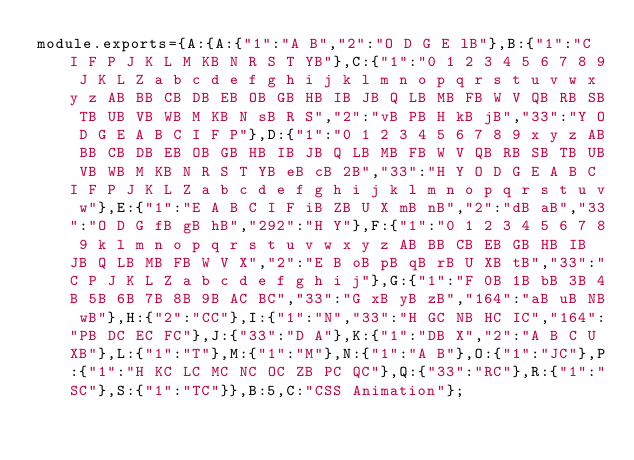Convert code to text. <code><loc_0><loc_0><loc_500><loc_500><_JavaScript_>module.exports={A:{A:{"1":"A B","2":"O D G E lB"},B:{"1":"C I F P J K L M KB N R S T YB"},C:{"1":"0 1 2 3 4 5 6 7 8 9 J K L Z a b c d e f g h i j k l m n o p q r s t u v w x y z AB BB CB DB EB OB GB HB IB JB Q LB MB FB W V QB RB SB TB UB VB WB M KB N sB R S","2":"vB PB H kB jB","33":"Y O D G E A B C I F P"},D:{"1":"0 1 2 3 4 5 6 7 8 9 x y z AB BB CB DB EB OB GB HB IB JB Q LB MB FB W V QB RB SB TB UB VB WB M KB N R S T YB eB cB 2B","33":"H Y O D G E A B C I F P J K L Z a b c d e f g h i j k l m n o p q r s t u v w"},E:{"1":"E A B C I F iB ZB U X mB nB","2":"dB aB","33":"O D G fB gB hB","292":"H Y"},F:{"1":"0 1 2 3 4 5 6 7 8 9 k l m n o p q r s t u v w x y z AB BB CB EB GB HB IB JB Q LB MB FB W V X","2":"E B oB pB qB rB U XB tB","33":"C P J K L Z a b c d e f g h i j"},G:{"1":"F 0B 1B bB 3B 4B 5B 6B 7B 8B 9B AC BC","33":"G xB yB zB","164":"aB uB NB wB"},H:{"2":"CC"},I:{"1":"N","33":"H GC NB HC IC","164":"PB DC EC FC"},J:{"33":"D A"},K:{"1":"DB X","2":"A B C U XB"},L:{"1":"T"},M:{"1":"M"},N:{"1":"A B"},O:{"1":"JC"},P:{"1":"H KC LC MC NC OC ZB PC QC"},Q:{"33":"RC"},R:{"1":"SC"},S:{"1":"TC"}},B:5,C:"CSS Animation"};
</code> 